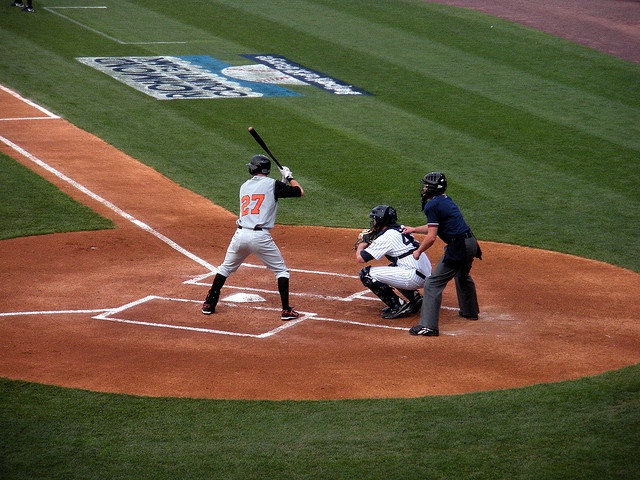Describe the objects in this image and their specific colors. I can see people in black, lavender, gray, and brown tones, people in black, gray, navy, and brown tones, people in black, lavender, darkgray, and gray tones, baseball glove in black, gray, beige, and brown tones, and baseball bat in black, gray, and maroon tones in this image. 